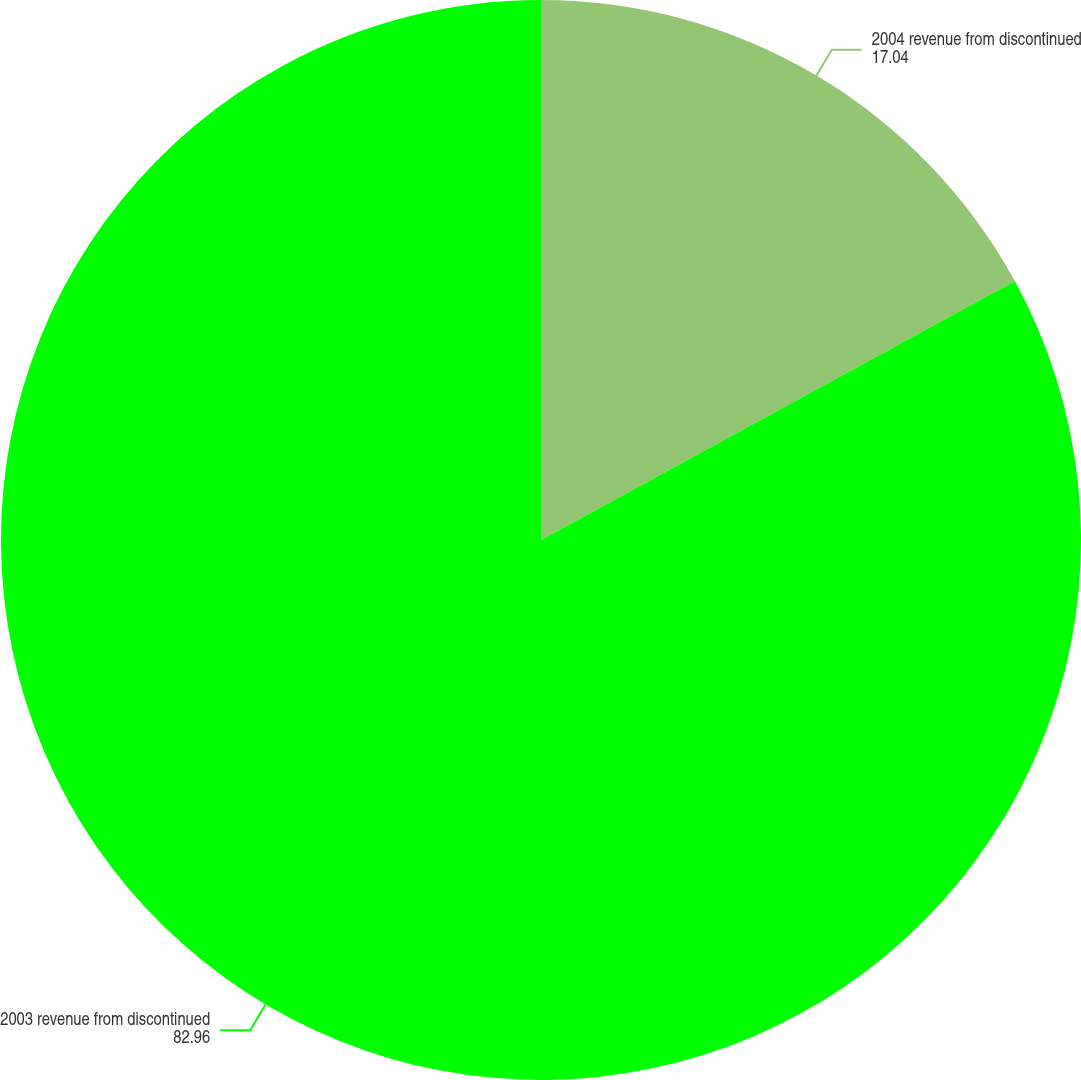Convert chart. <chart><loc_0><loc_0><loc_500><loc_500><pie_chart><fcel>2004 revenue from discontinued<fcel>2003 revenue from discontinued<nl><fcel>17.04%<fcel>82.96%<nl></chart> 